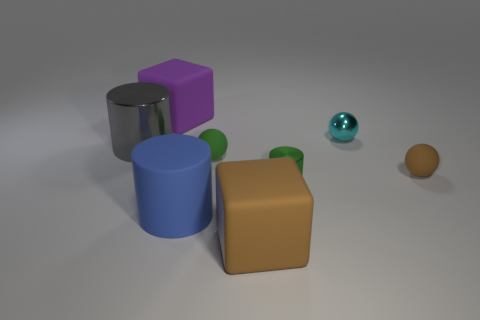Is there another matte thing of the same shape as the big brown rubber thing?
Ensure brevity in your answer.  Yes. Is the number of large objects that are on the right side of the cyan shiny sphere less than the number of tiny things?
Offer a terse response. Yes. Is the shape of the cyan shiny object the same as the small brown object?
Make the answer very short. Yes. There is a brown matte object right of the green cylinder; what is its size?
Ensure brevity in your answer.  Small. The green thing that is the same material as the big purple cube is what size?
Your answer should be compact. Small. Are there fewer tiny green rubber things than big blue balls?
Keep it short and to the point. No. There is a brown object that is the same size as the purple matte object; what is its material?
Ensure brevity in your answer.  Rubber. Is the number of green cubes greater than the number of cyan metal balls?
Provide a short and direct response. No. How many other objects are there of the same color as the small cylinder?
Ensure brevity in your answer.  1. What number of matte cubes are behind the rubber cylinder and to the right of the blue object?
Keep it short and to the point. 0. 